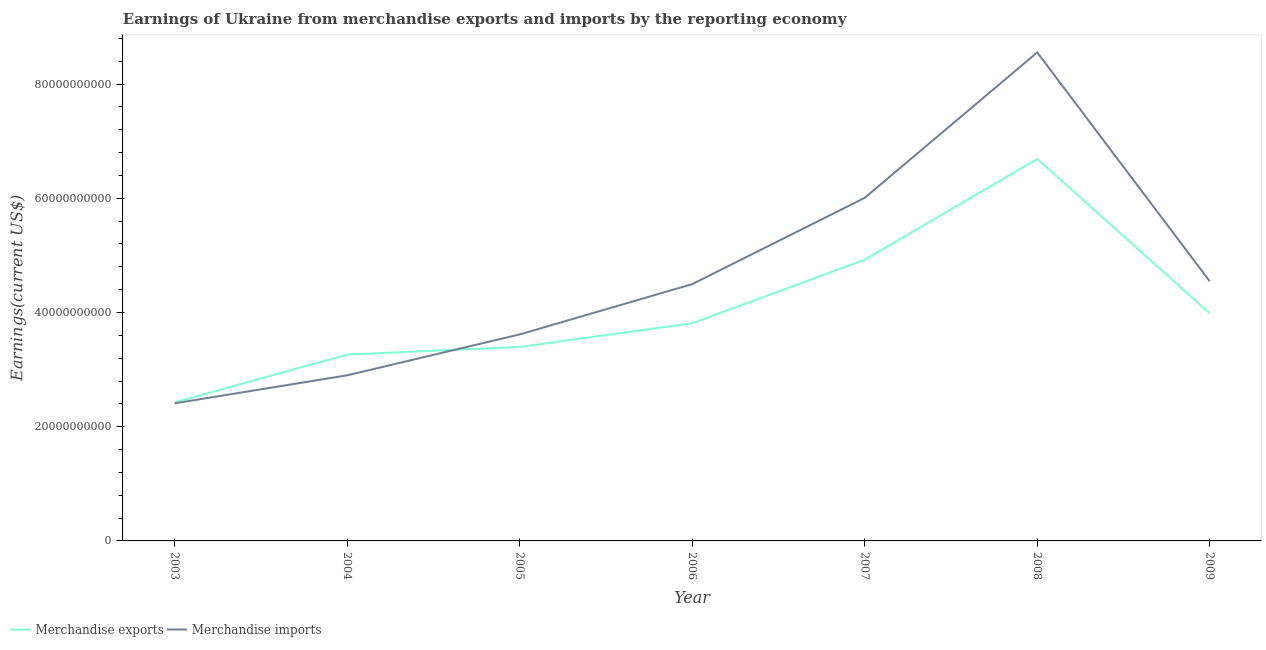Is the number of lines equal to the number of legend labels?
Offer a terse response. Yes. What is the earnings from merchandise exports in 2005?
Offer a very short reply. 3.40e+1. Across all years, what is the maximum earnings from merchandise imports?
Your answer should be very brief. 8.55e+1. Across all years, what is the minimum earnings from merchandise exports?
Offer a very short reply. 2.43e+1. In which year was the earnings from merchandise exports maximum?
Offer a terse response. 2008. In which year was the earnings from merchandise exports minimum?
Your answer should be compact. 2003. What is the total earnings from merchandise exports in the graph?
Keep it short and to the point. 2.85e+11. What is the difference between the earnings from merchandise exports in 2005 and that in 2006?
Provide a short and direct response. -4.15e+09. What is the difference between the earnings from merchandise exports in 2007 and the earnings from merchandise imports in 2009?
Keep it short and to the point. 3.79e+09. What is the average earnings from merchandise exports per year?
Your answer should be compact. 4.07e+1. In the year 2009, what is the difference between the earnings from merchandise imports and earnings from merchandise exports?
Offer a terse response. 5.64e+09. In how many years, is the earnings from merchandise imports greater than 24000000000 US$?
Ensure brevity in your answer.  7. What is the ratio of the earnings from merchandise imports in 2006 to that in 2008?
Provide a succinct answer. 0.53. Is the earnings from merchandise imports in 2004 less than that in 2007?
Keep it short and to the point. Yes. Is the difference between the earnings from merchandise exports in 2006 and 2009 greater than the difference between the earnings from merchandise imports in 2006 and 2009?
Your answer should be very brief. No. What is the difference between the highest and the second highest earnings from merchandise exports?
Give a very brief answer. 1.76e+1. What is the difference between the highest and the lowest earnings from merchandise exports?
Your answer should be compact. 4.26e+1. Does the earnings from merchandise imports monotonically increase over the years?
Your answer should be very brief. No. Is the earnings from merchandise exports strictly greater than the earnings from merchandise imports over the years?
Give a very brief answer. No. Is the earnings from merchandise exports strictly less than the earnings from merchandise imports over the years?
Offer a very short reply. No. How many lines are there?
Your response must be concise. 2. Where does the legend appear in the graph?
Provide a succinct answer. Bottom left. How many legend labels are there?
Provide a succinct answer. 2. What is the title of the graph?
Offer a very short reply. Earnings of Ukraine from merchandise exports and imports by the reporting economy. Does "Pregnant women" appear as one of the legend labels in the graph?
Provide a succinct answer. No. What is the label or title of the Y-axis?
Your response must be concise. Earnings(current US$). What is the Earnings(current US$) in Merchandise exports in 2003?
Give a very brief answer. 2.43e+1. What is the Earnings(current US$) of Merchandise imports in 2003?
Provide a succinct answer. 2.41e+1. What is the Earnings(current US$) in Merchandise exports in 2004?
Ensure brevity in your answer.  3.26e+1. What is the Earnings(current US$) of Merchandise imports in 2004?
Offer a terse response. 2.90e+1. What is the Earnings(current US$) of Merchandise exports in 2005?
Provide a short and direct response. 3.40e+1. What is the Earnings(current US$) in Merchandise imports in 2005?
Offer a very short reply. 3.62e+1. What is the Earnings(current US$) in Merchandise exports in 2006?
Your answer should be compact. 3.81e+1. What is the Earnings(current US$) of Merchandise imports in 2006?
Offer a terse response. 4.50e+1. What is the Earnings(current US$) of Merchandise exports in 2007?
Provide a short and direct response. 4.92e+1. What is the Earnings(current US$) of Merchandise imports in 2007?
Your answer should be very brief. 6.01e+1. What is the Earnings(current US$) of Merchandise exports in 2008?
Provide a short and direct response. 6.69e+1. What is the Earnings(current US$) in Merchandise imports in 2008?
Provide a succinct answer. 8.55e+1. What is the Earnings(current US$) in Merchandise exports in 2009?
Your answer should be compact. 3.98e+1. What is the Earnings(current US$) of Merchandise imports in 2009?
Keep it short and to the point. 4.55e+1. Across all years, what is the maximum Earnings(current US$) in Merchandise exports?
Your response must be concise. 6.69e+1. Across all years, what is the maximum Earnings(current US$) in Merchandise imports?
Offer a terse response. 8.55e+1. Across all years, what is the minimum Earnings(current US$) in Merchandise exports?
Give a very brief answer. 2.43e+1. Across all years, what is the minimum Earnings(current US$) in Merchandise imports?
Provide a short and direct response. 2.41e+1. What is the total Earnings(current US$) in Merchandise exports in the graph?
Give a very brief answer. 2.85e+11. What is the total Earnings(current US$) in Merchandise imports in the graph?
Keep it short and to the point. 3.25e+11. What is the difference between the Earnings(current US$) of Merchandise exports in 2003 and that in 2004?
Your answer should be very brief. -8.36e+09. What is the difference between the Earnings(current US$) in Merchandise imports in 2003 and that in 2004?
Offer a terse response. -4.90e+09. What is the difference between the Earnings(current US$) of Merchandise exports in 2003 and that in 2005?
Give a very brief answer. -9.70e+09. What is the difference between the Earnings(current US$) in Merchandise imports in 2003 and that in 2005?
Your answer should be very brief. -1.21e+1. What is the difference between the Earnings(current US$) of Merchandise exports in 2003 and that in 2006?
Your response must be concise. -1.38e+1. What is the difference between the Earnings(current US$) of Merchandise imports in 2003 and that in 2006?
Your response must be concise. -2.09e+1. What is the difference between the Earnings(current US$) of Merchandise exports in 2003 and that in 2007?
Your response must be concise. -2.50e+1. What is the difference between the Earnings(current US$) of Merchandise imports in 2003 and that in 2007?
Make the answer very short. -3.60e+1. What is the difference between the Earnings(current US$) in Merchandise exports in 2003 and that in 2008?
Provide a succinct answer. -4.26e+1. What is the difference between the Earnings(current US$) in Merchandise imports in 2003 and that in 2008?
Provide a short and direct response. -6.14e+1. What is the difference between the Earnings(current US$) of Merchandise exports in 2003 and that in 2009?
Keep it short and to the point. -1.56e+1. What is the difference between the Earnings(current US$) in Merchandise imports in 2003 and that in 2009?
Your answer should be compact. -2.14e+1. What is the difference between the Earnings(current US$) in Merchandise exports in 2004 and that in 2005?
Make the answer very short. -1.33e+09. What is the difference between the Earnings(current US$) of Merchandise imports in 2004 and that in 2005?
Your answer should be compact. -7.16e+09. What is the difference between the Earnings(current US$) of Merchandise exports in 2004 and that in 2006?
Make the answer very short. -5.48e+09. What is the difference between the Earnings(current US$) of Merchandise imports in 2004 and that in 2006?
Give a very brief answer. -1.60e+1. What is the difference between the Earnings(current US$) in Merchandise exports in 2004 and that in 2007?
Keep it short and to the point. -1.66e+1. What is the difference between the Earnings(current US$) in Merchandise imports in 2004 and that in 2007?
Your answer should be compact. -3.11e+1. What is the difference between the Earnings(current US$) of Merchandise exports in 2004 and that in 2008?
Offer a terse response. -3.42e+1. What is the difference between the Earnings(current US$) in Merchandise imports in 2004 and that in 2008?
Your response must be concise. -5.65e+1. What is the difference between the Earnings(current US$) of Merchandise exports in 2004 and that in 2009?
Offer a very short reply. -7.19e+09. What is the difference between the Earnings(current US$) of Merchandise imports in 2004 and that in 2009?
Keep it short and to the point. -1.65e+1. What is the difference between the Earnings(current US$) of Merchandise exports in 2005 and that in 2006?
Provide a short and direct response. -4.15e+09. What is the difference between the Earnings(current US$) in Merchandise imports in 2005 and that in 2006?
Offer a terse response. -8.81e+09. What is the difference between the Earnings(current US$) of Merchandise exports in 2005 and that in 2007?
Ensure brevity in your answer.  -1.53e+1. What is the difference between the Earnings(current US$) of Merchandise imports in 2005 and that in 2007?
Ensure brevity in your answer.  -2.39e+1. What is the difference between the Earnings(current US$) of Merchandise exports in 2005 and that in 2008?
Provide a succinct answer. -3.29e+1. What is the difference between the Earnings(current US$) of Merchandise imports in 2005 and that in 2008?
Your response must be concise. -4.94e+1. What is the difference between the Earnings(current US$) of Merchandise exports in 2005 and that in 2009?
Make the answer very short. -5.86e+09. What is the difference between the Earnings(current US$) of Merchandise imports in 2005 and that in 2009?
Keep it short and to the point. -9.31e+09. What is the difference between the Earnings(current US$) in Merchandise exports in 2006 and that in 2007?
Provide a short and direct response. -1.11e+1. What is the difference between the Earnings(current US$) of Merchandise imports in 2006 and that in 2007?
Provide a short and direct response. -1.51e+1. What is the difference between the Earnings(current US$) of Merchandise exports in 2006 and that in 2008?
Make the answer very short. -2.88e+1. What is the difference between the Earnings(current US$) in Merchandise imports in 2006 and that in 2008?
Your answer should be compact. -4.06e+1. What is the difference between the Earnings(current US$) in Merchandise exports in 2006 and that in 2009?
Offer a terse response. -1.71e+09. What is the difference between the Earnings(current US$) of Merchandise imports in 2006 and that in 2009?
Provide a short and direct response. -5.01e+08. What is the difference between the Earnings(current US$) of Merchandise exports in 2007 and that in 2008?
Your answer should be compact. -1.76e+1. What is the difference between the Earnings(current US$) of Merchandise imports in 2007 and that in 2008?
Offer a terse response. -2.55e+1. What is the difference between the Earnings(current US$) of Merchandise exports in 2007 and that in 2009?
Your answer should be compact. 9.42e+09. What is the difference between the Earnings(current US$) of Merchandise imports in 2007 and that in 2009?
Provide a succinct answer. 1.46e+1. What is the difference between the Earnings(current US$) in Merchandise exports in 2008 and that in 2009?
Your answer should be very brief. 2.71e+1. What is the difference between the Earnings(current US$) of Merchandise imports in 2008 and that in 2009?
Your answer should be very brief. 4.01e+1. What is the difference between the Earnings(current US$) in Merchandise exports in 2003 and the Earnings(current US$) in Merchandise imports in 2004?
Make the answer very short. -4.72e+09. What is the difference between the Earnings(current US$) of Merchandise exports in 2003 and the Earnings(current US$) of Merchandise imports in 2005?
Provide a short and direct response. -1.19e+1. What is the difference between the Earnings(current US$) of Merchandise exports in 2003 and the Earnings(current US$) of Merchandise imports in 2006?
Your answer should be compact. -2.07e+1. What is the difference between the Earnings(current US$) in Merchandise exports in 2003 and the Earnings(current US$) in Merchandise imports in 2007?
Your answer should be very brief. -3.58e+1. What is the difference between the Earnings(current US$) of Merchandise exports in 2003 and the Earnings(current US$) of Merchandise imports in 2008?
Offer a very short reply. -6.13e+1. What is the difference between the Earnings(current US$) of Merchandise exports in 2003 and the Earnings(current US$) of Merchandise imports in 2009?
Offer a very short reply. -2.12e+1. What is the difference between the Earnings(current US$) in Merchandise exports in 2004 and the Earnings(current US$) in Merchandise imports in 2005?
Keep it short and to the point. -3.52e+09. What is the difference between the Earnings(current US$) of Merchandise exports in 2004 and the Earnings(current US$) of Merchandise imports in 2006?
Your answer should be compact. -1.23e+1. What is the difference between the Earnings(current US$) of Merchandise exports in 2004 and the Earnings(current US$) of Merchandise imports in 2007?
Offer a terse response. -2.74e+1. What is the difference between the Earnings(current US$) of Merchandise exports in 2004 and the Earnings(current US$) of Merchandise imports in 2008?
Your answer should be very brief. -5.29e+1. What is the difference between the Earnings(current US$) of Merchandise exports in 2004 and the Earnings(current US$) of Merchandise imports in 2009?
Ensure brevity in your answer.  -1.28e+1. What is the difference between the Earnings(current US$) in Merchandise exports in 2005 and the Earnings(current US$) in Merchandise imports in 2006?
Your answer should be compact. -1.10e+1. What is the difference between the Earnings(current US$) in Merchandise exports in 2005 and the Earnings(current US$) in Merchandise imports in 2007?
Your answer should be very brief. -2.61e+1. What is the difference between the Earnings(current US$) of Merchandise exports in 2005 and the Earnings(current US$) of Merchandise imports in 2008?
Ensure brevity in your answer.  -5.16e+1. What is the difference between the Earnings(current US$) of Merchandise exports in 2005 and the Earnings(current US$) of Merchandise imports in 2009?
Ensure brevity in your answer.  -1.15e+1. What is the difference between the Earnings(current US$) in Merchandise exports in 2006 and the Earnings(current US$) in Merchandise imports in 2007?
Your response must be concise. -2.20e+1. What is the difference between the Earnings(current US$) of Merchandise exports in 2006 and the Earnings(current US$) of Merchandise imports in 2008?
Your answer should be very brief. -4.74e+1. What is the difference between the Earnings(current US$) of Merchandise exports in 2006 and the Earnings(current US$) of Merchandise imports in 2009?
Keep it short and to the point. -7.35e+09. What is the difference between the Earnings(current US$) of Merchandise exports in 2007 and the Earnings(current US$) of Merchandise imports in 2008?
Ensure brevity in your answer.  -3.63e+1. What is the difference between the Earnings(current US$) of Merchandise exports in 2007 and the Earnings(current US$) of Merchandise imports in 2009?
Give a very brief answer. 3.79e+09. What is the difference between the Earnings(current US$) of Merchandise exports in 2008 and the Earnings(current US$) of Merchandise imports in 2009?
Offer a very short reply. 2.14e+1. What is the average Earnings(current US$) of Merchandise exports per year?
Offer a terse response. 4.07e+1. What is the average Earnings(current US$) in Merchandise imports per year?
Provide a short and direct response. 4.65e+1. In the year 2003, what is the difference between the Earnings(current US$) of Merchandise exports and Earnings(current US$) of Merchandise imports?
Your answer should be very brief. 1.80e+08. In the year 2004, what is the difference between the Earnings(current US$) of Merchandise exports and Earnings(current US$) of Merchandise imports?
Make the answer very short. 3.64e+09. In the year 2005, what is the difference between the Earnings(current US$) of Merchandise exports and Earnings(current US$) of Merchandise imports?
Your answer should be compact. -2.19e+09. In the year 2006, what is the difference between the Earnings(current US$) of Merchandise exports and Earnings(current US$) of Merchandise imports?
Provide a succinct answer. -6.84e+09. In the year 2007, what is the difference between the Earnings(current US$) of Merchandise exports and Earnings(current US$) of Merchandise imports?
Your response must be concise. -1.08e+1. In the year 2008, what is the difference between the Earnings(current US$) in Merchandise exports and Earnings(current US$) in Merchandise imports?
Make the answer very short. -1.87e+1. In the year 2009, what is the difference between the Earnings(current US$) of Merchandise exports and Earnings(current US$) of Merchandise imports?
Make the answer very short. -5.64e+09. What is the ratio of the Earnings(current US$) in Merchandise exports in 2003 to that in 2004?
Ensure brevity in your answer.  0.74. What is the ratio of the Earnings(current US$) in Merchandise imports in 2003 to that in 2004?
Provide a short and direct response. 0.83. What is the ratio of the Earnings(current US$) in Merchandise exports in 2003 to that in 2005?
Offer a very short reply. 0.71. What is the ratio of the Earnings(current US$) of Merchandise imports in 2003 to that in 2005?
Your answer should be compact. 0.67. What is the ratio of the Earnings(current US$) of Merchandise exports in 2003 to that in 2006?
Make the answer very short. 0.64. What is the ratio of the Earnings(current US$) of Merchandise imports in 2003 to that in 2006?
Give a very brief answer. 0.54. What is the ratio of the Earnings(current US$) of Merchandise exports in 2003 to that in 2007?
Your answer should be compact. 0.49. What is the ratio of the Earnings(current US$) of Merchandise imports in 2003 to that in 2007?
Give a very brief answer. 0.4. What is the ratio of the Earnings(current US$) in Merchandise exports in 2003 to that in 2008?
Your answer should be very brief. 0.36. What is the ratio of the Earnings(current US$) of Merchandise imports in 2003 to that in 2008?
Offer a very short reply. 0.28. What is the ratio of the Earnings(current US$) of Merchandise exports in 2003 to that in 2009?
Provide a short and direct response. 0.61. What is the ratio of the Earnings(current US$) of Merchandise imports in 2003 to that in 2009?
Make the answer very short. 0.53. What is the ratio of the Earnings(current US$) of Merchandise exports in 2004 to that in 2005?
Keep it short and to the point. 0.96. What is the ratio of the Earnings(current US$) in Merchandise imports in 2004 to that in 2005?
Keep it short and to the point. 0.8. What is the ratio of the Earnings(current US$) of Merchandise exports in 2004 to that in 2006?
Provide a succinct answer. 0.86. What is the ratio of the Earnings(current US$) of Merchandise imports in 2004 to that in 2006?
Make the answer very short. 0.64. What is the ratio of the Earnings(current US$) in Merchandise exports in 2004 to that in 2007?
Your response must be concise. 0.66. What is the ratio of the Earnings(current US$) in Merchandise imports in 2004 to that in 2007?
Ensure brevity in your answer.  0.48. What is the ratio of the Earnings(current US$) in Merchandise exports in 2004 to that in 2008?
Keep it short and to the point. 0.49. What is the ratio of the Earnings(current US$) in Merchandise imports in 2004 to that in 2008?
Offer a very short reply. 0.34. What is the ratio of the Earnings(current US$) of Merchandise exports in 2004 to that in 2009?
Keep it short and to the point. 0.82. What is the ratio of the Earnings(current US$) of Merchandise imports in 2004 to that in 2009?
Provide a short and direct response. 0.64. What is the ratio of the Earnings(current US$) of Merchandise exports in 2005 to that in 2006?
Make the answer very short. 0.89. What is the ratio of the Earnings(current US$) in Merchandise imports in 2005 to that in 2006?
Offer a very short reply. 0.8. What is the ratio of the Earnings(current US$) in Merchandise exports in 2005 to that in 2007?
Your answer should be compact. 0.69. What is the ratio of the Earnings(current US$) in Merchandise imports in 2005 to that in 2007?
Make the answer very short. 0.6. What is the ratio of the Earnings(current US$) in Merchandise exports in 2005 to that in 2008?
Offer a terse response. 0.51. What is the ratio of the Earnings(current US$) in Merchandise imports in 2005 to that in 2008?
Keep it short and to the point. 0.42. What is the ratio of the Earnings(current US$) in Merchandise exports in 2005 to that in 2009?
Make the answer very short. 0.85. What is the ratio of the Earnings(current US$) of Merchandise imports in 2005 to that in 2009?
Make the answer very short. 0.8. What is the ratio of the Earnings(current US$) in Merchandise exports in 2006 to that in 2007?
Your answer should be compact. 0.77. What is the ratio of the Earnings(current US$) in Merchandise imports in 2006 to that in 2007?
Your answer should be compact. 0.75. What is the ratio of the Earnings(current US$) in Merchandise exports in 2006 to that in 2008?
Your answer should be compact. 0.57. What is the ratio of the Earnings(current US$) in Merchandise imports in 2006 to that in 2008?
Offer a very short reply. 0.53. What is the ratio of the Earnings(current US$) in Merchandise exports in 2006 to that in 2009?
Offer a very short reply. 0.96. What is the ratio of the Earnings(current US$) of Merchandise exports in 2007 to that in 2008?
Your answer should be very brief. 0.74. What is the ratio of the Earnings(current US$) of Merchandise imports in 2007 to that in 2008?
Provide a succinct answer. 0.7. What is the ratio of the Earnings(current US$) of Merchandise exports in 2007 to that in 2009?
Provide a short and direct response. 1.24. What is the ratio of the Earnings(current US$) of Merchandise imports in 2007 to that in 2009?
Provide a succinct answer. 1.32. What is the ratio of the Earnings(current US$) of Merchandise exports in 2008 to that in 2009?
Make the answer very short. 1.68. What is the ratio of the Earnings(current US$) in Merchandise imports in 2008 to that in 2009?
Your answer should be very brief. 1.88. What is the difference between the highest and the second highest Earnings(current US$) of Merchandise exports?
Make the answer very short. 1.76e+1. What is the difference between the highest and the second highest Earnings(current US$) in Merchandise imports?
Keep it short and to the point. 2.55e+1. What is the difference between the highest and the lowest Earnings(current US$) in Merchandise exports?
Provide a succinct answer. 4.26e+1. What is the difference between the highest and the lowest Earnings(current US$) of Merchandise imports?
Provide a succinct answer. 6.14e+1. 